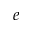Convert formula to latex. <formula><loc_0><loc_0><loc_500><loc_500>e</formula> 